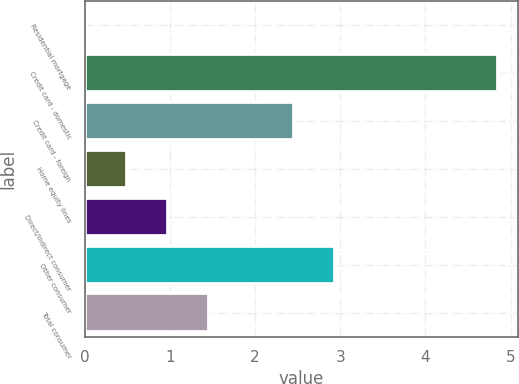Convert chart to OTSL. <chart><loc_0><loc_0><loc_500><loc_500><bar_chart><fcel>Residential mortgage<fcel>Credit card - domestic<fcel>Credit card - foreign<fcel>Home equity lines<fcel>Direct/Indirect consumer<fcel>Other consumer<fcel>Total consumer<nl><fcel>0.02<fcel>4.85<fcel>2.46<fcel>0.5<fcel>0.98<fcel>2.94<fcel>1.46<nl></chart> 